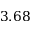Convert formula to latex. <formula><loc_0><loc_0><loc_500><loc_500>3 . 6 8</formula> 